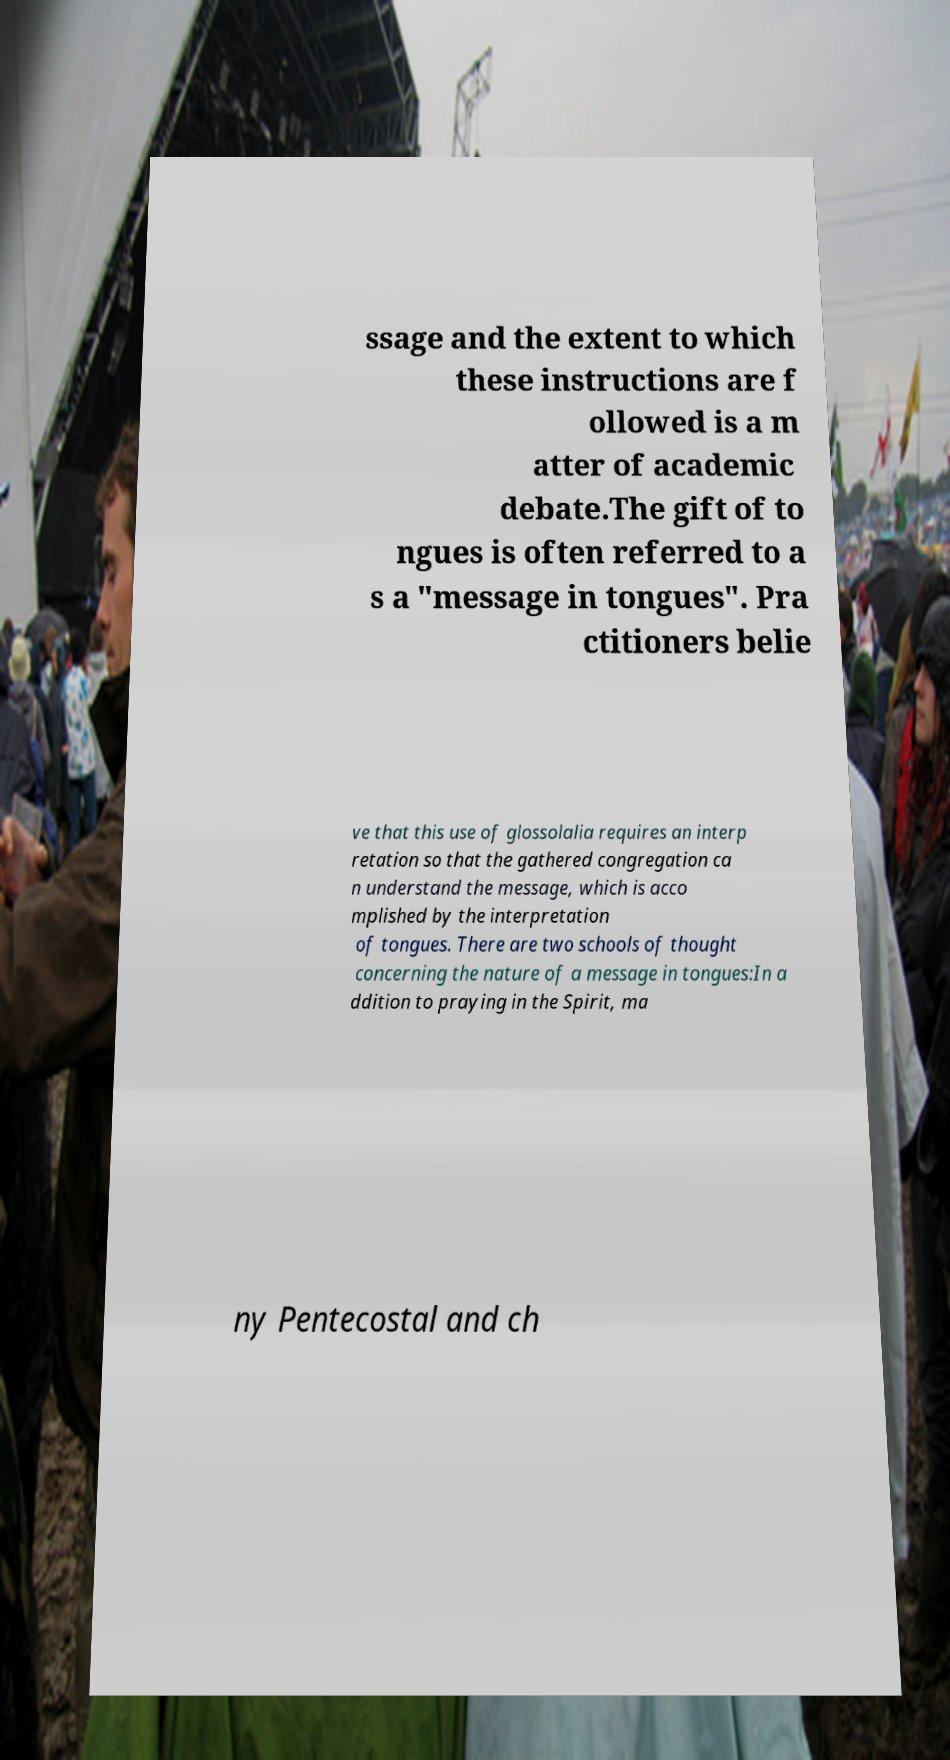For documentation purposes, I need the text within this image transcribed. Could you provide that? ssage and the extent to which these instructions are f ollowed is a m atter of academic debate.The gift of to ngues is often referred to a s a "message in tongues". Pra ctitioners belie ve that this use of glossolalia requires an interp retation so that the gathered congregation ca n understand the message, which is acco mplished by the interpretation of tongues. There are two schools of thought concerning the nature of a message in tongues:In a ddition to praying in the Spirit, ma ny Pentecostal and ch 